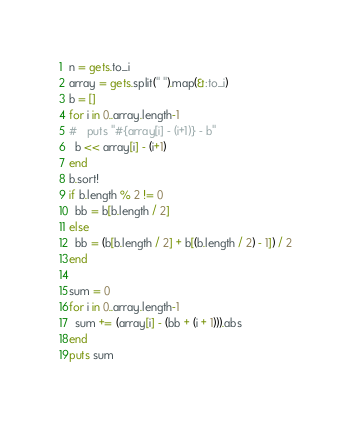Convert code to text. <code><loc_0><loc_0><loc_500><loc_500><_Ruby_>n = gets.to_i
array = gets.split(" ").map(&:to_i)
b = []
for i in 0..array.length-1
#   puts "#{array[i] - (i+1)} - b"
  b << array[i] - (i+1)
end
b.sort!
if b.length % 2 != 0
  bb = b[b.length / 2]
else
  bb = (b[b.length / 2] + b[(b.length / 2) - 1]) / 2
end

sum = 0
for i in 0..array.length-1
  sum += (array[i] - (bb + (i + 1))).abs
end
puts sum</code> 